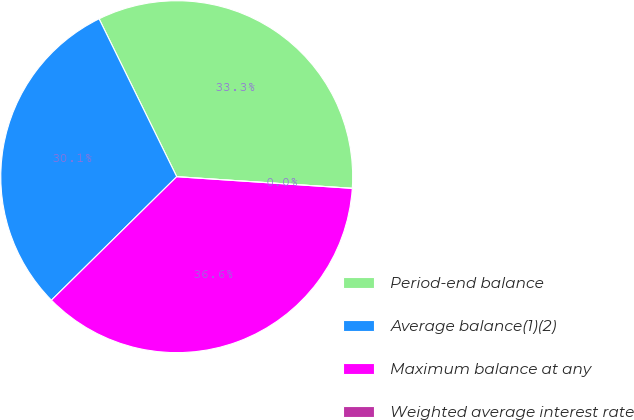Convert chart. <chart><loc_0><loc_0><loc_500><loc_500><pie_chart><fcel>Period-end balance<fcel>Average balance(1)(2)<fcel>Maximum balance at any<fcel>Weighted average interest rate<nl><fcel>33.33%<fcel>30.11%<fcel>36.56%<fcel>0.0%<nl></chart> 